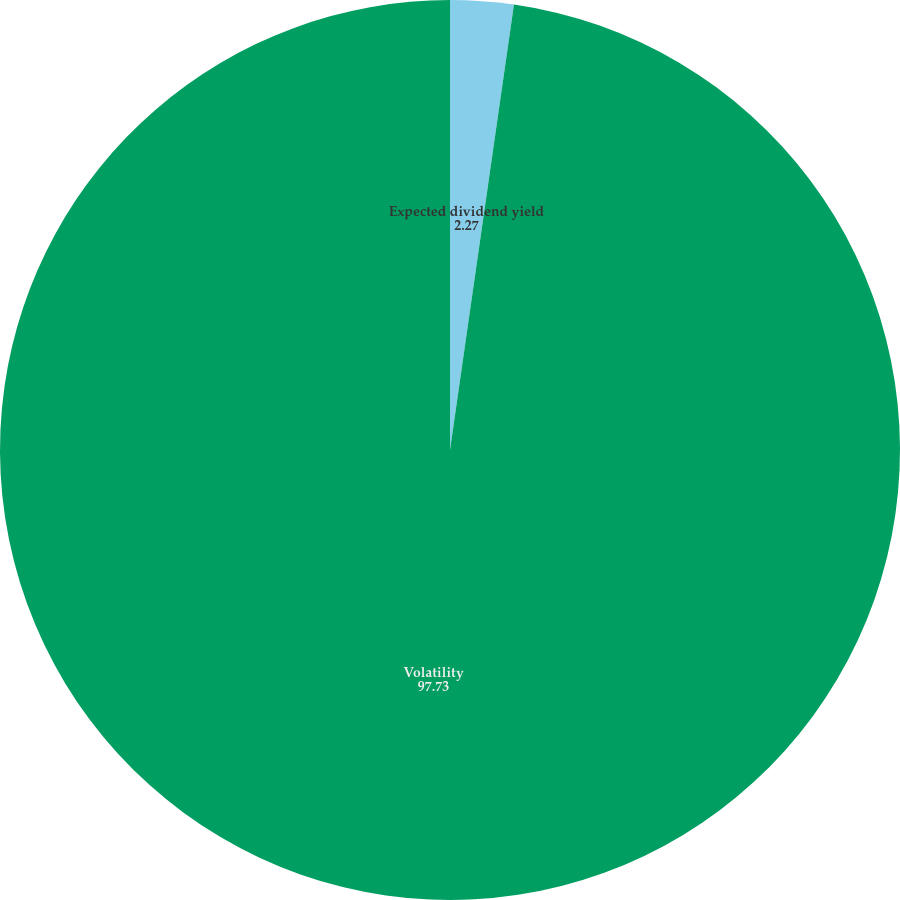Convert chart. <chart><loc_0><loc_0><loc_500><loc_500><pie_chart><fcel>Expected dividend yield<fcel>Volatility<nl><fcel>2.27%<fcel>97.73%<nl></chart> 